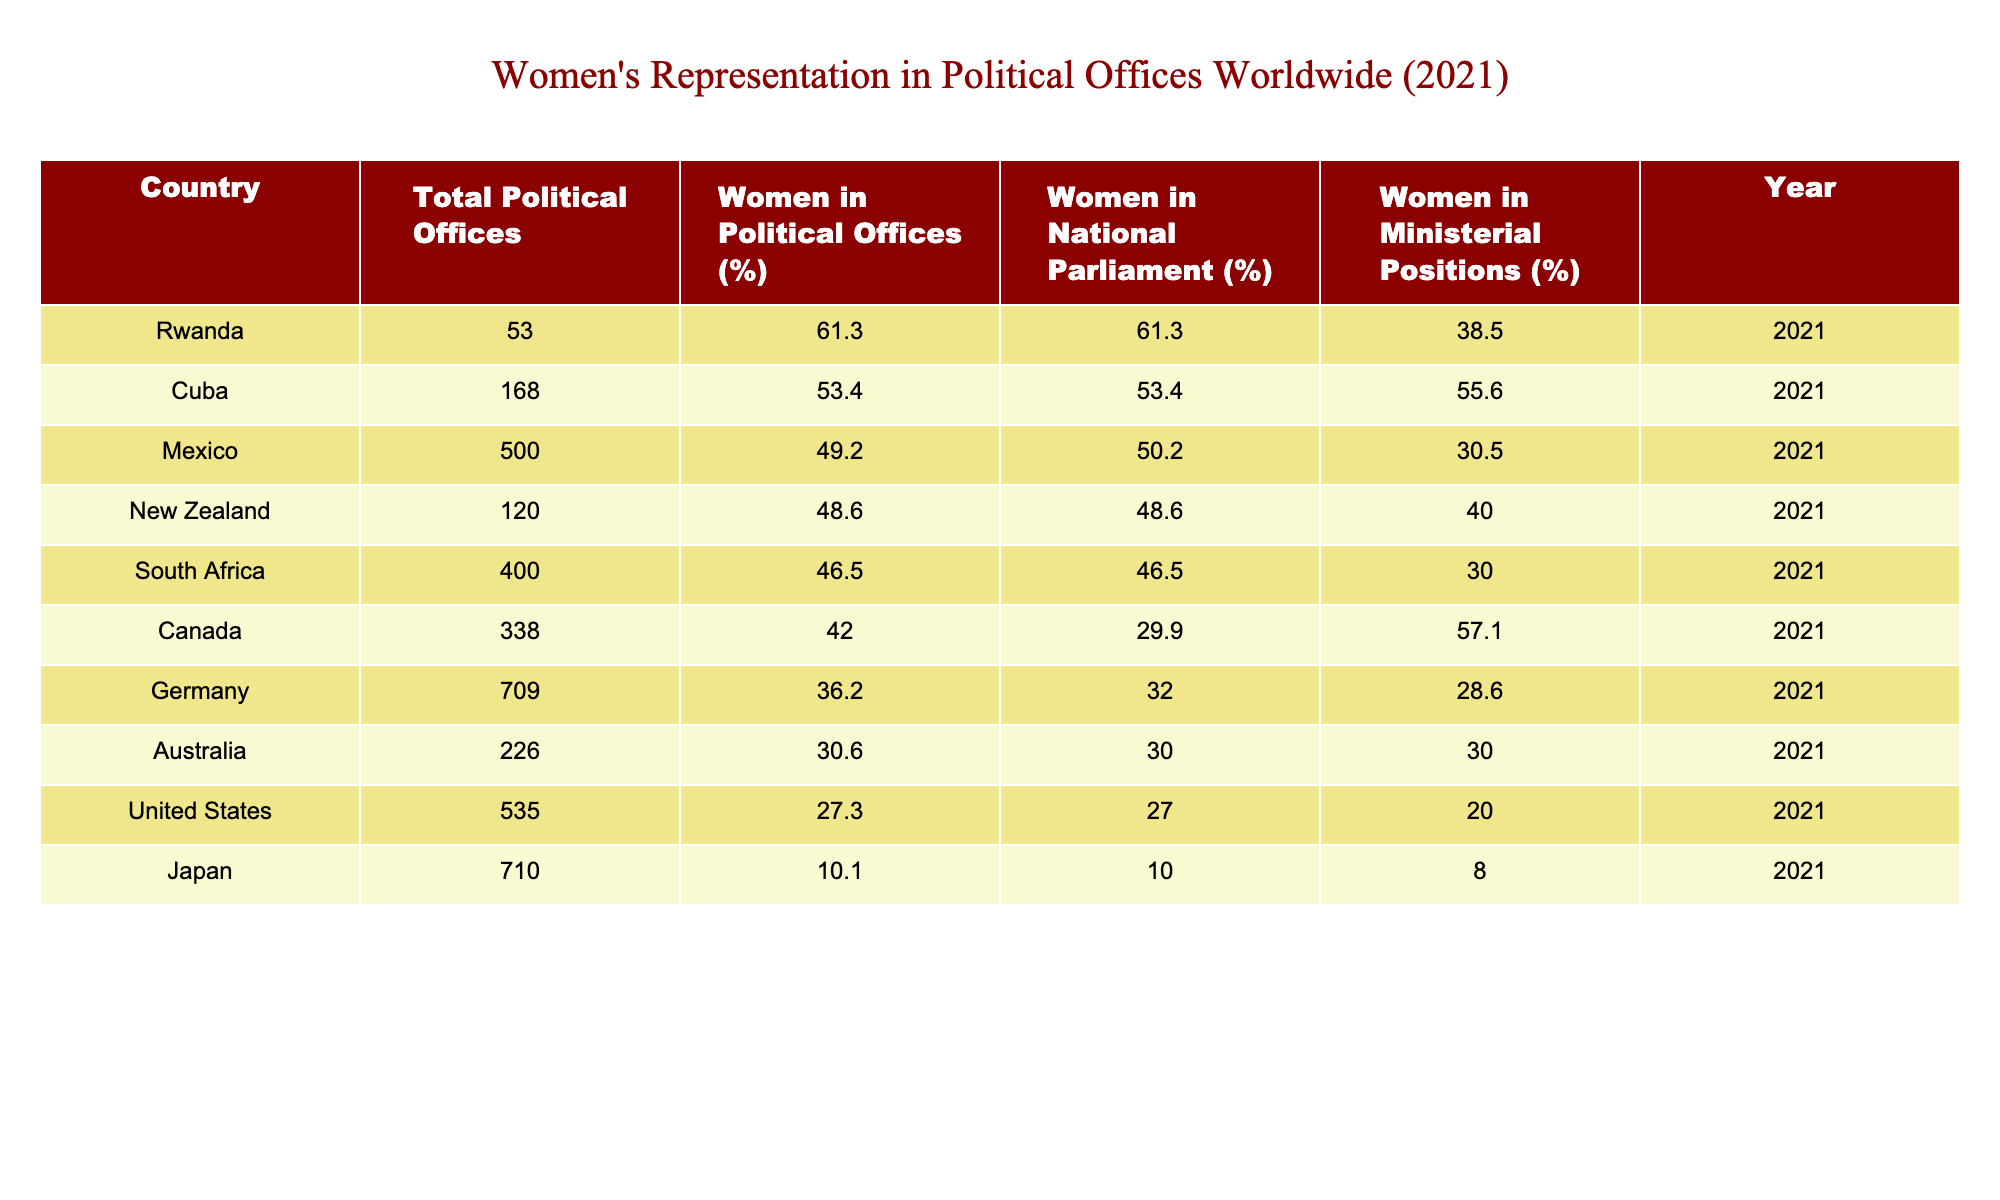What country has the highest percentage of women in political offices? By examining the 'Women in Political Offices (%)' column in the table, we see that Rwanda has the highest value at 61.3%.
Answer: Rwanda What is the percentage of women in national parliament in Germany? From the table, we can locate Germany and check its 'Women in National Parliament (%)' value, which is 32.0%.
Answer: 32.0% Which country has the lowest percentage of women in ministerial positions? By looking at the 'Women in Ministerial Positions (%)' column, we can find that Japan has the lowest value at 8.0%.
Answer: Japan What is the average percentage of women in political offices across all the listed countries? To find the average, we first sum all the percentages from the 'Women in Political Offices (%)' column, which totals to (61.3 + 53.4 + 49.2 + 48.6 + 46.5 + 42.0 + 36.2 + 30.6 + 27.3 + 10.1) = 404.8. There are 10 countries, so the average is 404.8 / 10 = 40.48%.
Answer: 40.48% Is it true that Canada has a higher percentage of women in ministerial positions than Mexico? Checking the respective 'Women in Ministerial Positions (%)', Canada has 57.1% and Mexico has 30.5%. Since 57.1% is greater than 30.5%, the statement is true.
Answer: Yes Which country has a greater difference in the percentage of women in political offices and women in national parliament than the average difference of 5%? To find this, we first calculate the difference for each country (Women in Political Offices - Women in National Parliament). For example, for Rwanda it is (61.3 - 61.3) = 0, while for the United States it is (27.3 - 27.0) = 0.3. After calculating all differences, we find that Mexico has (49.2 - 50.2) = -1.0, and Germany has (36.2 - 32.0) = 4.2, while others such as South Africa (46.5 - 46.5) = 0 and Canada (42.0 - 29.9) = 12.1 are significant. The only one exceeding the average difference would be Canada at 12.1%.
Answer: Canada What percentage of political offices held by women in the United States is higher than that in Japan? Referencing the respective percentages from the table, women in political offices in the United States are at 27.3%, whereas in Japan it is only 10.1%. Therefore, the percentage of women in political offices in the United States is indeed higher than in Japan.
Answer: Yes 